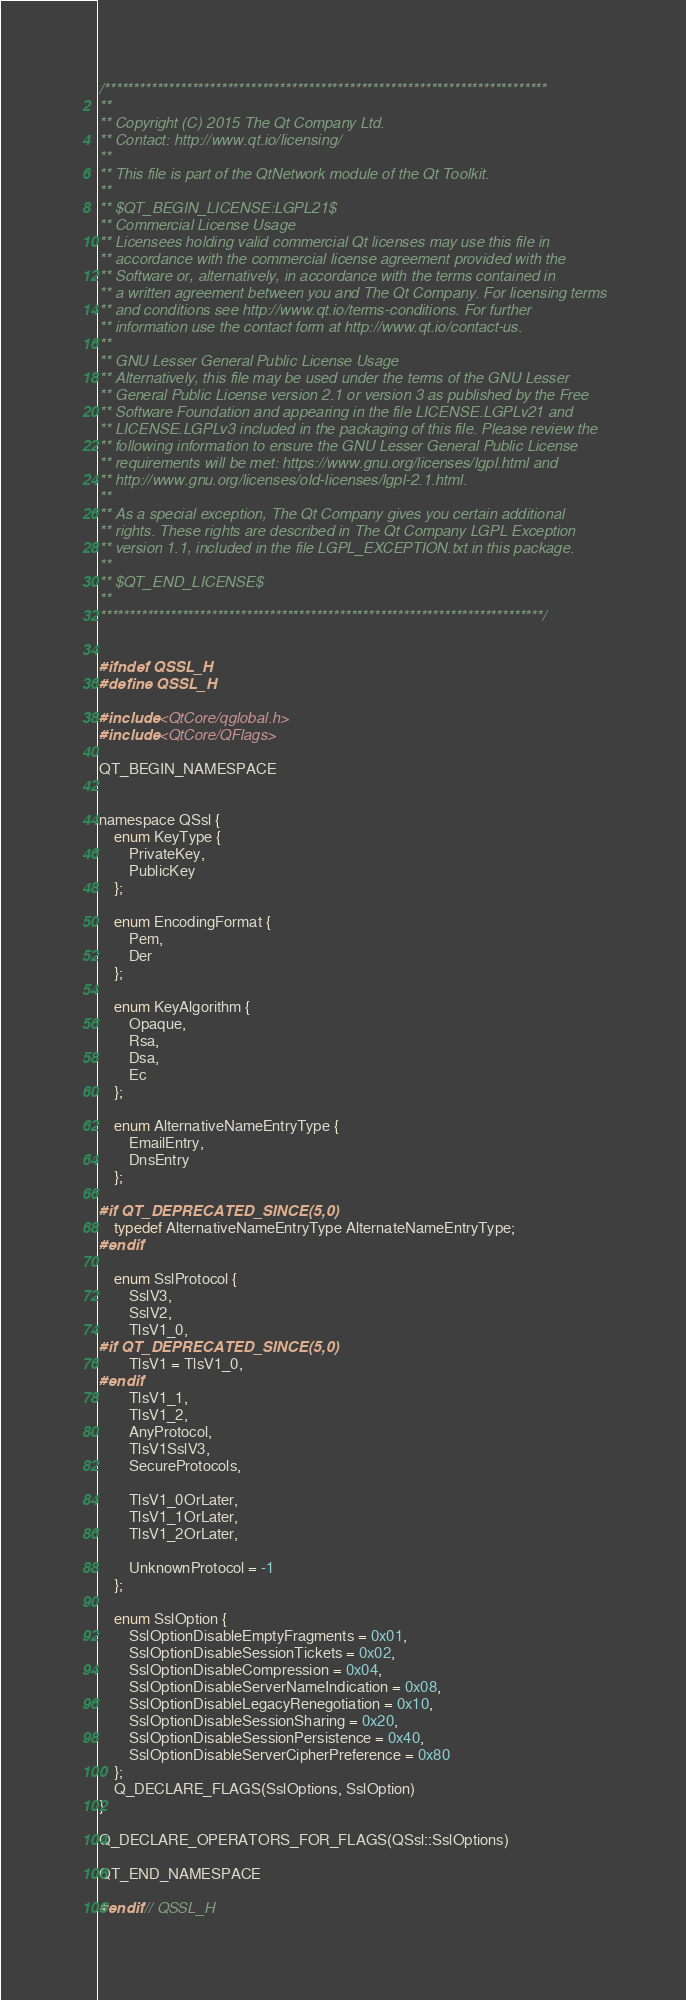<code> <loc_0><loc_0><loc_500><loc_500><_C_>/****************************************************************************
**
** Copyright (C) 2015 The Qt Company Ltd.
** Contact: http://www.qt.io/licensing/
**
** This file is part of the QtNetwork module of the Qt Toolkit.
**
** $QT_BEGIN_LICENSE:LGPL21$
** Commercial License Usage
** Licensees holding valid commercial Qt licenses may use this file in
** accordance with the commercial license agreement provided with the
** Software or, alternatively, in accordance with the terms contained in
** a written agreement between you and The Qt Company. For licensing terms
** and conditions see http://www.qt.io/terms-conditions. For further
** information use the contact form at http://www.qt.io/contact-us.
**
** GNU Lesser General Public License Usage
** Alternatively, this file may be used under the terms of the GNU Lesser
** General Public License version 2.1 or version 3 as published by the Free
** Software Foundation and appearing in the file LICENSE.LGPLv21 and
** LICENSE.LGPLv3 included in the packaging of this file. Please review the
** following information to ensure the GNU Lesser General Public License
** requirements will be met: https://www.gnu.org/licenses/lgpl.html and
** http://www.gnu.org/licenses/old-licenses/lgpl-2.1.html.
**
** As a special exception, The Qt Company gives you certain additional
** rights. These rights are described in The Qt Company LGPL Exception
** version 1.1, included in the file LGPL_EXCEPTION.txt in this package.
**
** $QT_END_LICENSE$
**
****************************************************************************/


#ifndef QSSL_H
#define QSSL_H

#include <QtCore/qglobal.h>
#include <QtCore/QFlags>

QT_BEGIN_NAMESPACE


namespace QSsl {
    enum KeyType {
        PrivateKey,
        PublicKey
    };

    enum EncodingFormat {
        Pem,
        Der
    };

    enum KeyAlgorithm {
        Opaque,
        Rsa,
        Dsa,
        Ec
    };

    enum AlternativeNameEntryType {
        EmailEntry,
        DnsEntry
    };

#if QT_DEPRECATED_SINCE(5,0)
    typedef AlternativeNameEntryType AlternateNameEntryType;
#endif

    enum SslProtocol {
        SslV3,
        SslV2,
        TlsV1_0,
#if QT_DEPRECATED_SINCE(5,0)
        TlsV1 = TlsV1_0,
#endif
        TlsV1_1,
        TlsV1_2,
        AnyProtocol,
        TlsV1SslV3,
        SecureProtocols,

        TlsV1_0OrLater,
        TlsV1_1OrLater,
        TlsV1_2OrLater,

        UnknownProtocol = -1
    };

    enum SslOption {
        SslOptionDisableEmptyFragments = 0x01,
        SslOptionDisableSessionTickets = 0x02,
        SslOptionDisableCompression = 0x04,
        SslOptionDisableServerNameIndication = 0x08,
        SslOptionDisableLegacyRenegotiation = 0x10,
        SslOptionDisableSessionSharing = 0x20,
        SslOptionDisableSessionPersistence = 0x40,
        SslOptionDisableServerCipherPreference = 0x80
    };
    Q_DECLARE_FLAGS(SslOptions, SslOption)
}

Q_DECLARE_OPERATORS_FOR_FLAGS(QSsl::SslOptions)

QT_END_NAMESPACE

#endif // QSSL_H
</code> 